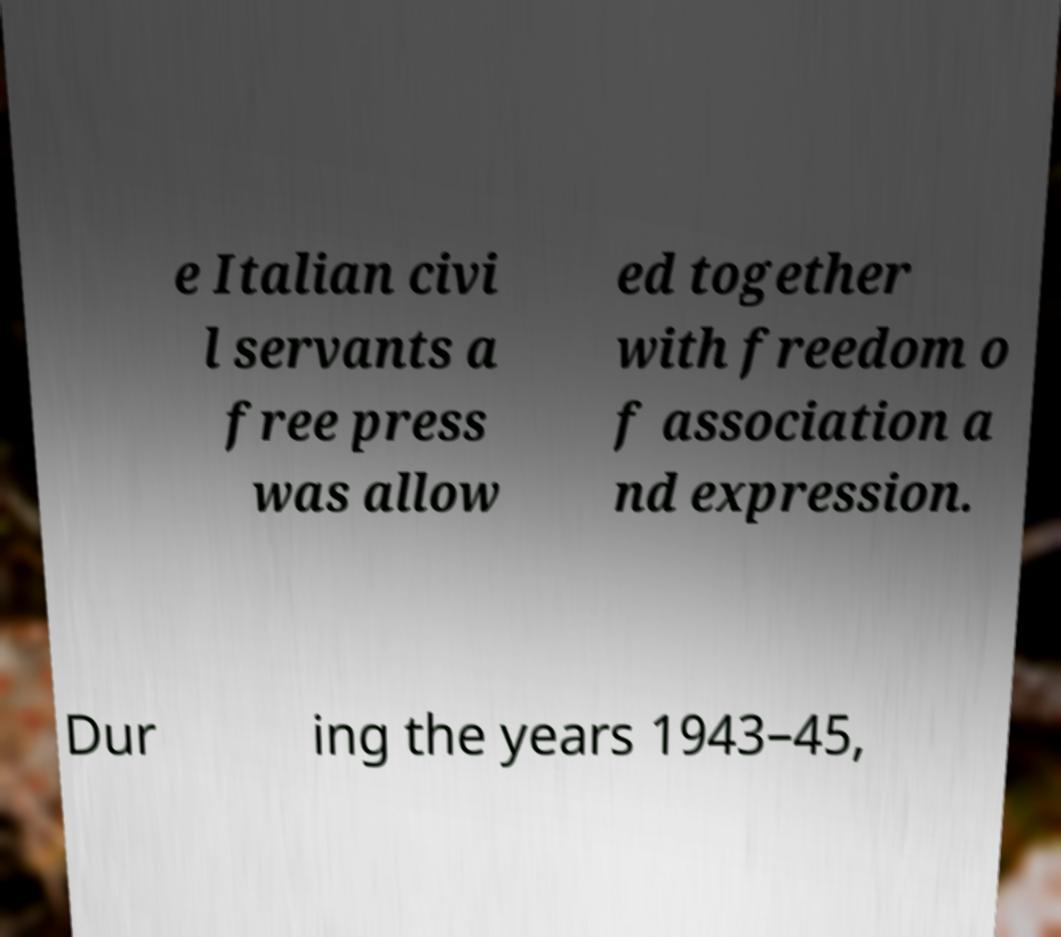Please read and relay the text visible in this image. What does it say? e Italian civi l servants a free press was allow ed together with freedom o f association a nd expression. Dur ing the years 1943–45, 